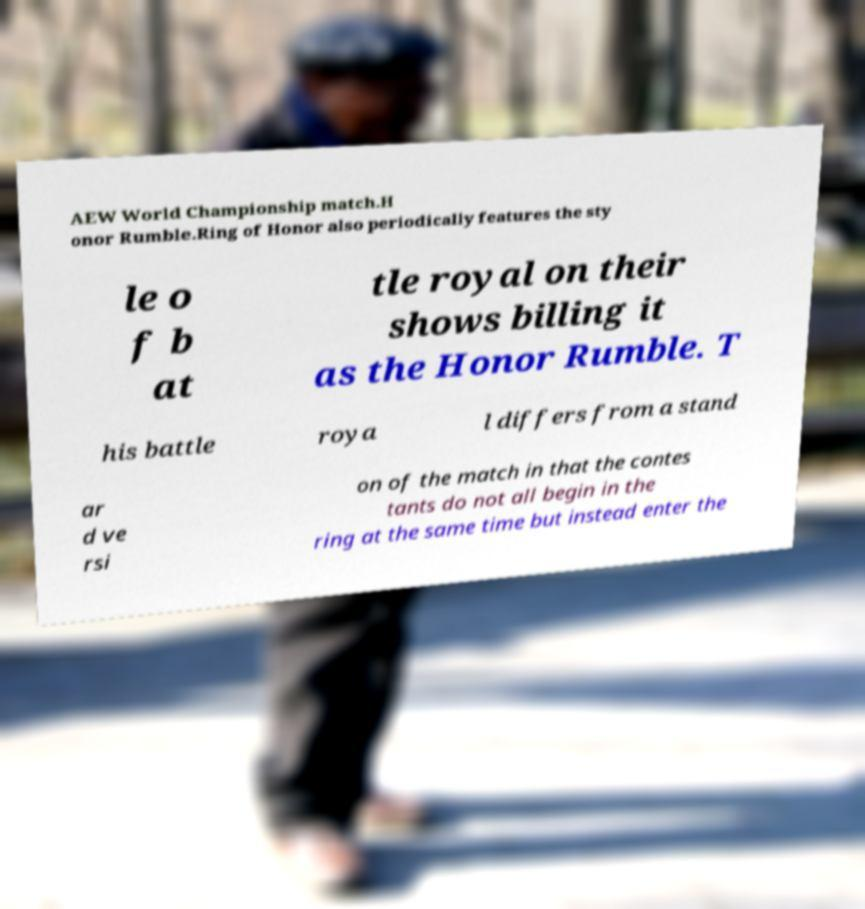For documentation purposes, I need the text within this image transcribed. Could you provide that? AEW World Championship match.H onor Rumble.Ring of Honor also periodically features the sty le o f b at tle royal on their shows billing it as the Honor Rumble. T his battle roya l differs from a stand ar d ve rsi on of the match in that the contes tants do not all begin in the ring at the same time but instead enter the 